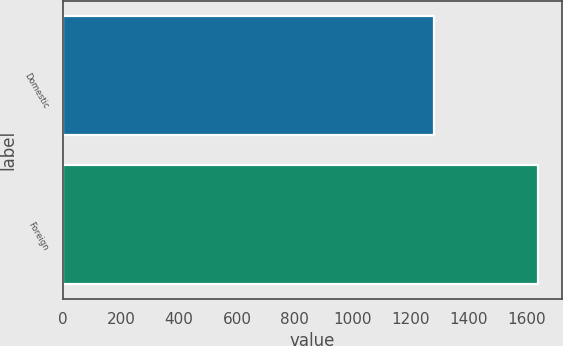Convert chart to OTSL. <chart><loc_0><loc_0><loc_500><loc_500><bar_chart><fcel>Domestic<fcel>Foreign<nl><fcel>1282<fcel>1640<nl></chart> 